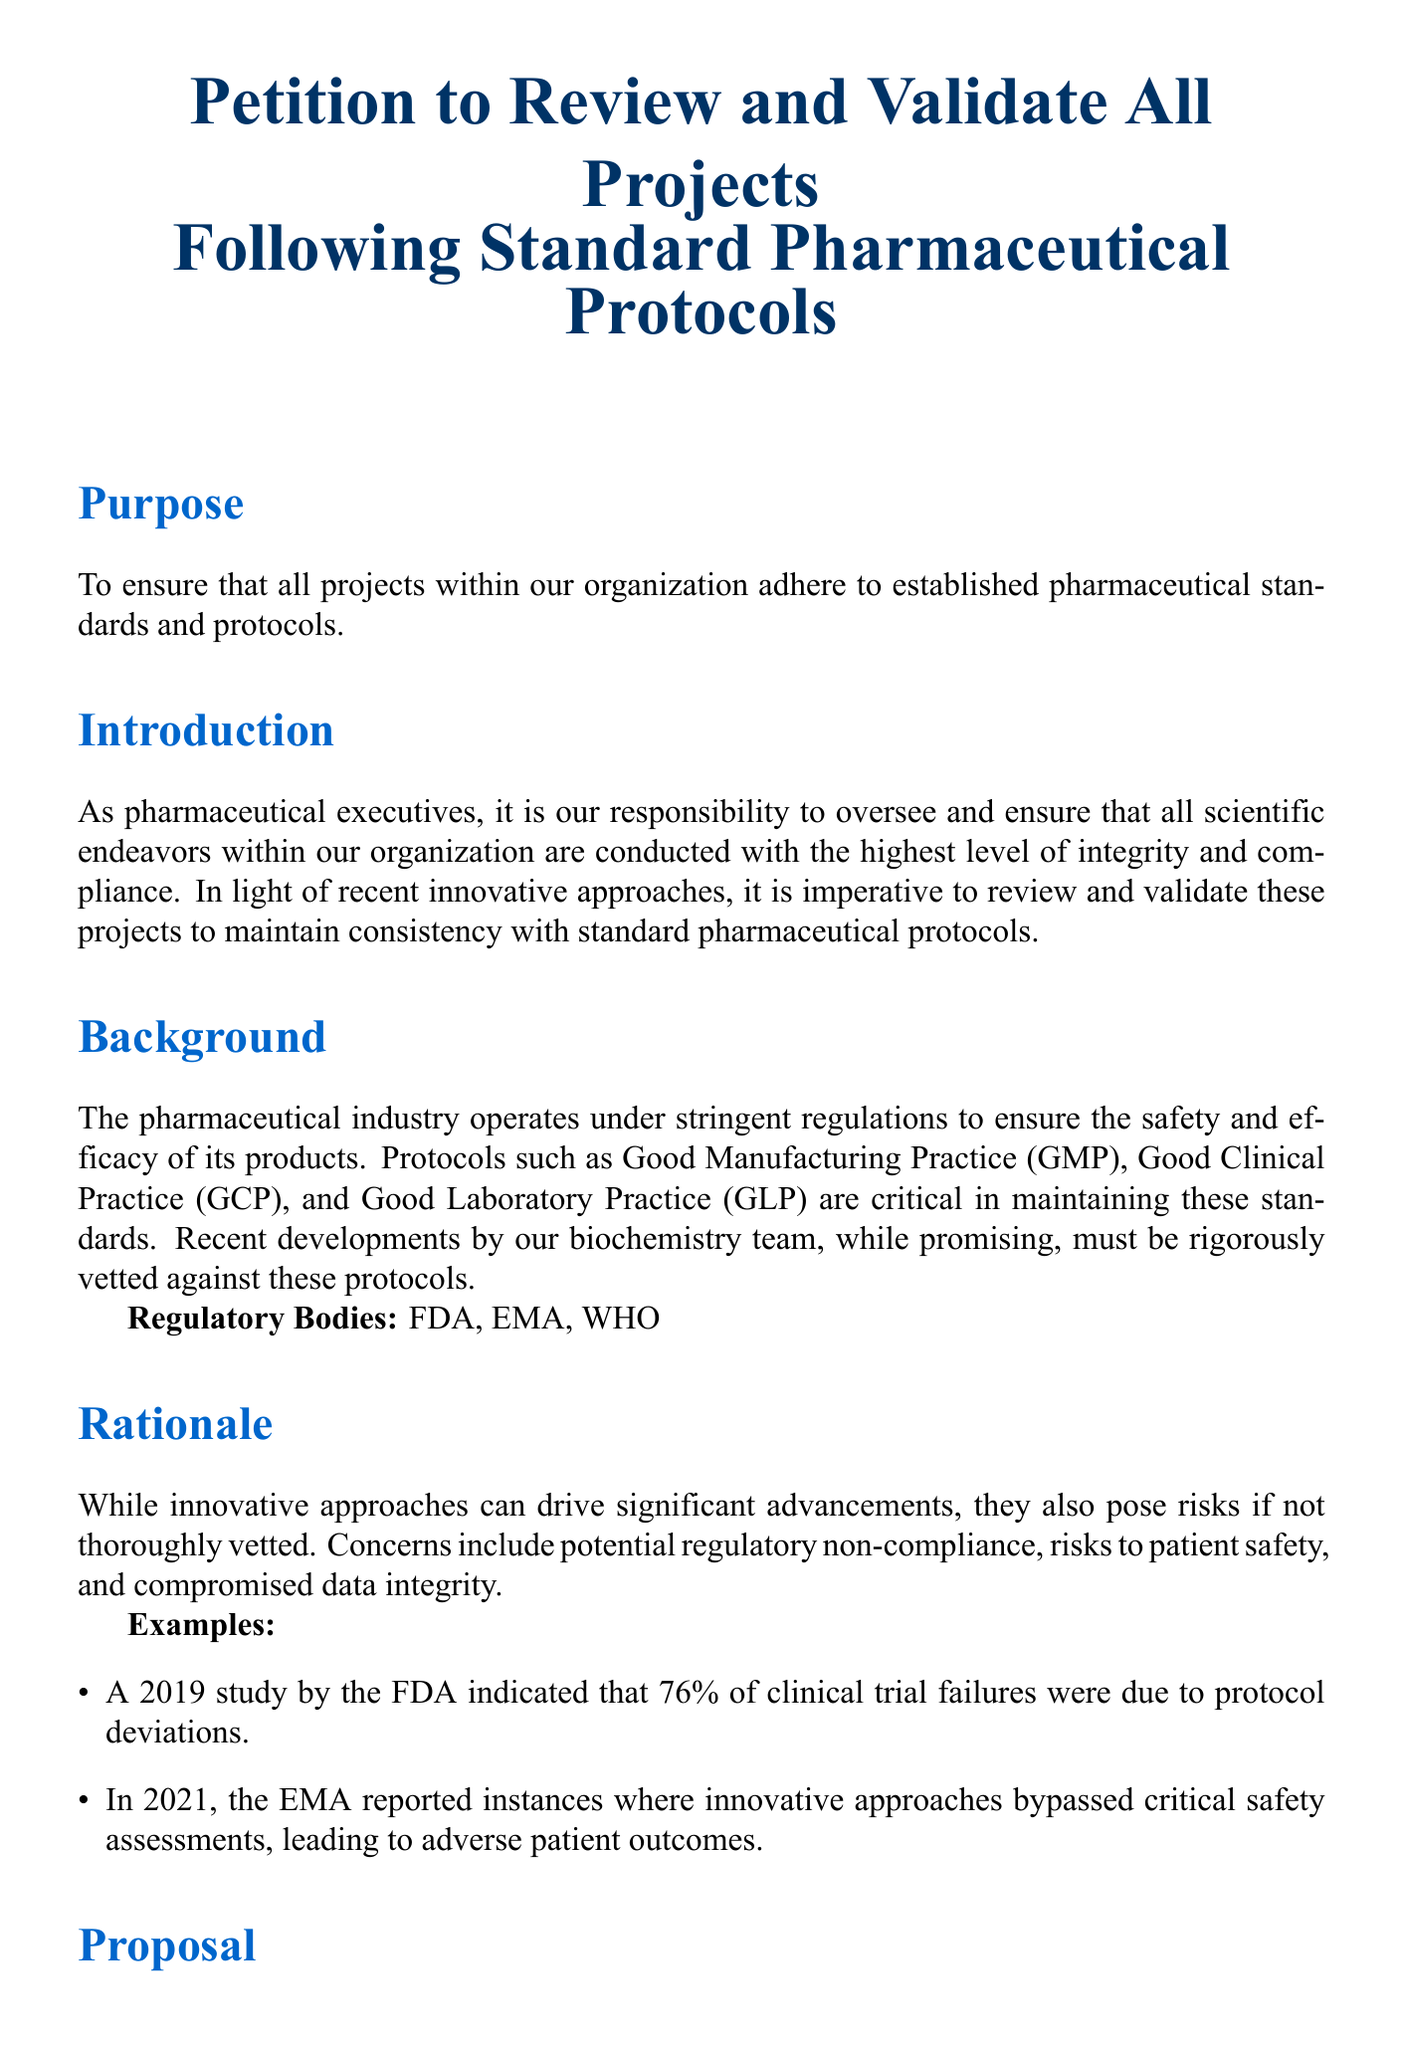What is the title of the document? The title reflects the main subject of the petition, which is to ensure adherence to established protocols.
Answer: Petition to Review and Validate All Projects Following Standard Pharmaceutical Protocols What regulatory bodies are mentioned? The regulatory bodies are specified to indicate the standards expected to be upheld in the industry.
Answer: FDA, EMA, WHO What percentage of clinical trial failures were due to protocol deviations according to the 2019 study? This percentage illustrates the importance of following established protocols to prevent failures in trials.
Answer: 76% What is one of the proposed actions in the document? This action is part of the measures recommended to ensure compliance with pharmaceutical protocols.
Answer: Establish an independent review board What are two of the critical protocols mentioned? These protocols are vital to maintaining safety and efficacy in pharmaceutical projects.
Answer: GMP, GCP, GLP What is the main rationale behind the petition? Understanding the rationale helps to clarify the potential risks if innovative approaches are not properly vetted.
Answer: Risks to patient safety Who are the signatories of the petition? The signatories represent the leadership of the organization advocating for this review and validation.
Answer: John Doe, Jane Smith What is the purpose of the petition? The purpose defines the intention behind proposing the actions outlined in the document.
Answer: Ensure adherence to established pharmaceutical standards 